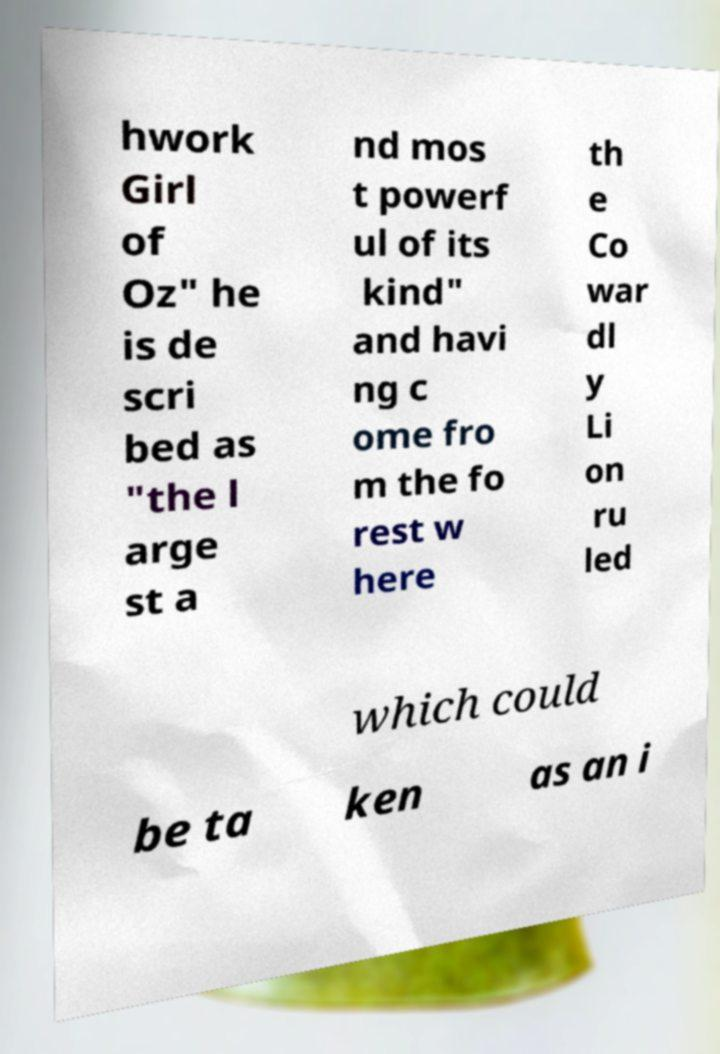Could you assist in decoding the text presented in this image and type it out clearly? hwork Girl of Oz" he is de scri bed as "the l arge st a nd mos t powerf ul of its kind" and havi ng c ome fro m the fo rest w here th e Co war dl y Li on ru led which could be ta ken as an i 